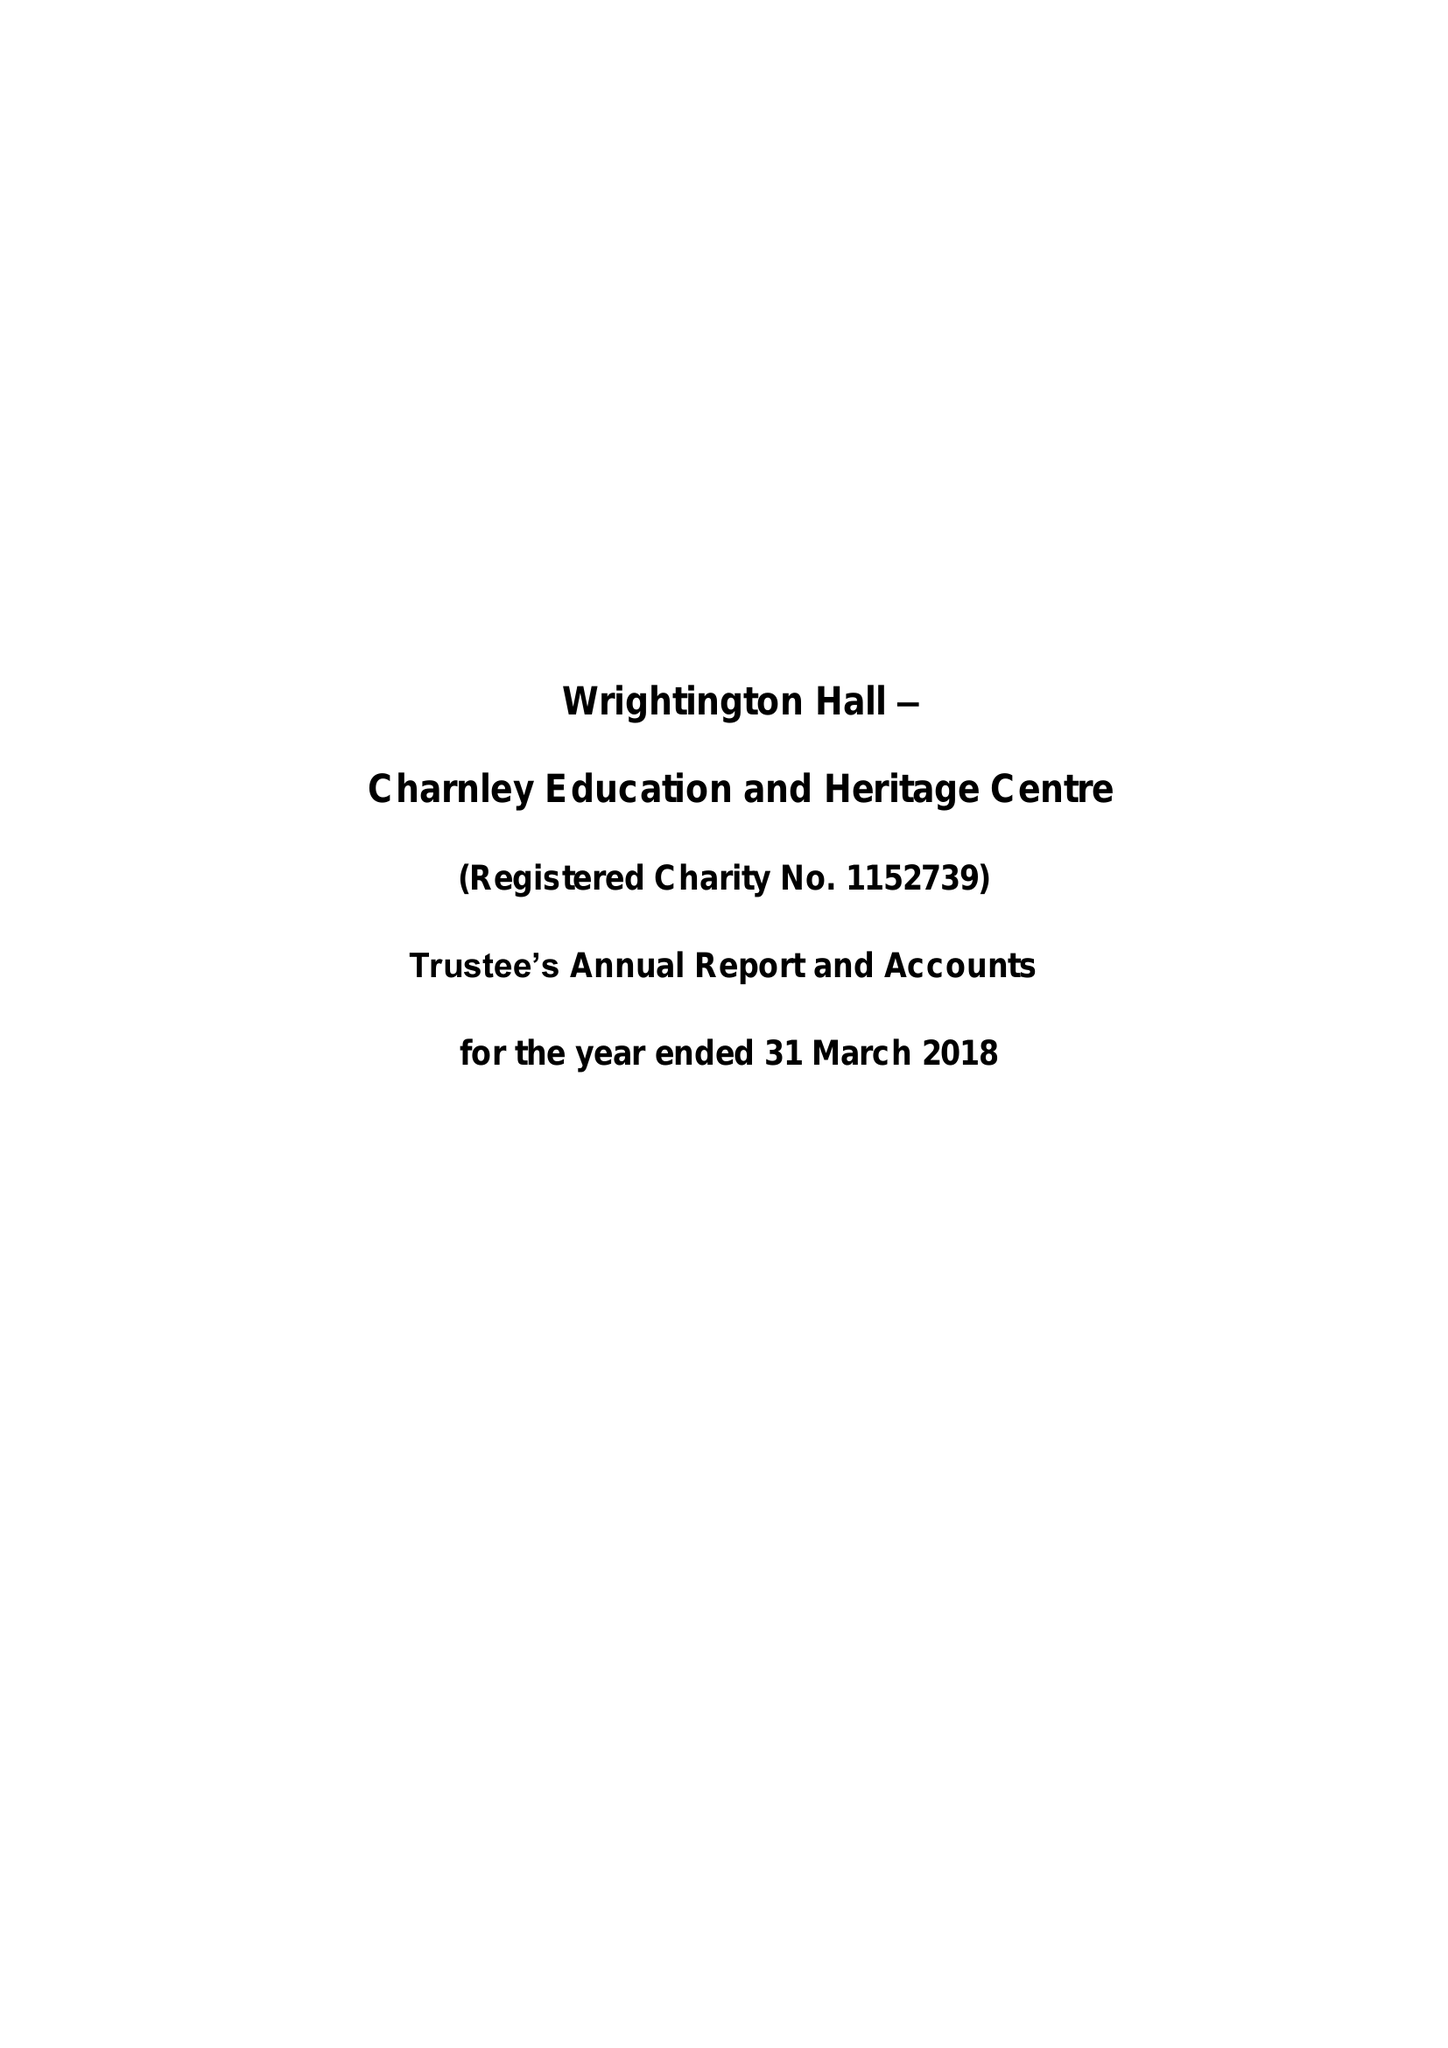What is the value for the address__post_town?
Answer the question using a single word or phrase. CHORLEY 